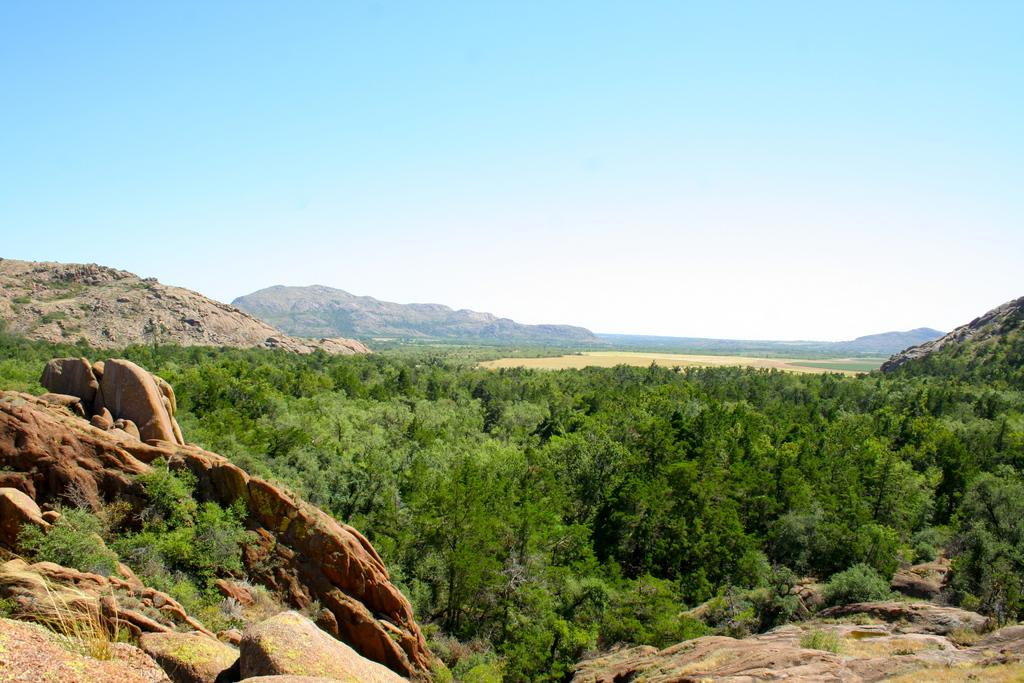What type of natural elements can be seen in the image? There are rocks and trees in the image. What type of landscape is depicted in the background of the image? There are mountains in the background of the image. What can be seen in the sky in the image? There are clouds and the sky is visible in the background of the image. What type of chair is the laborer sitting on in the image? There is no chair or laborer present in the image; it features rocks, trees, mountains, clouds, and the sky. How many wheels can be seen on the vehicle in the image? There is no vehicle or wheel present in the image. 